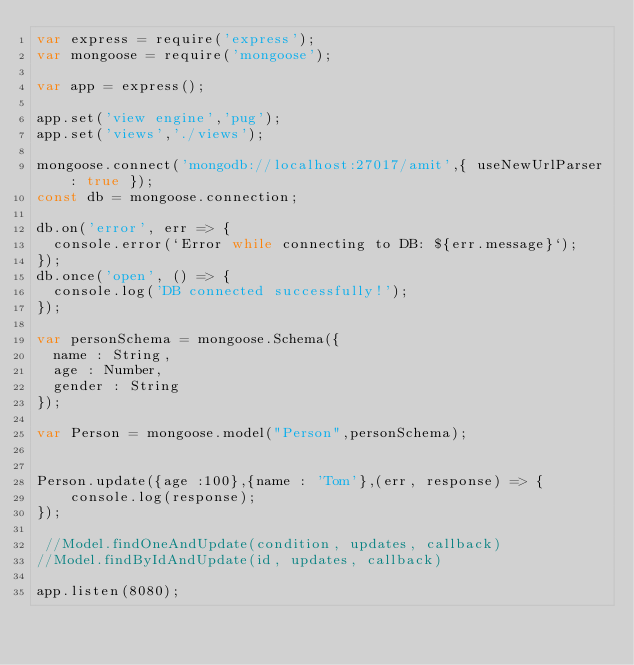Convert code to text. <code><loc_0><loc_0><loc_500><loc_500><_JavaScript_>var express = require('express');
var mongoose = require('mongoose');

var app = express();

app.set('view engine','pug');
app.set('views','./views');

mongoose.connect('mongodb://localhost:27017/amit',{ useNewUrlParser: true });
const db = mongoose.connection;

db.on('error', err => {
  console.error(`Error while connecting to DB: ${err.message}`);
});
db.once('open', () => {
  console.log('DB connected successfully!');
});

var personSchema = mongoose.Schema({
  name : String,
  age : Number,
  gender : String
});

var Person = mongoose.model("Person",personSchema);


Person.update({age :100},{name : 'Tom'},(err, response) => {
    console.log(response);
});

 //Model.findOneAndUpdate(condition, updates, callback)
//Model.findByIdAndUpdate(id, updates, callback)

app.listen(8080);</code> 